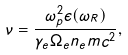<formula> <loc_0><loc_0><loc_500><loc_500>\nu = \frac { \omega ^ { 2 } _ { p } \epsilon ( \omega _ { R } ) } { \gamma _ { e } \Omega _ { e } n _ { e } m c ^ { 2 } } ,</formula> 